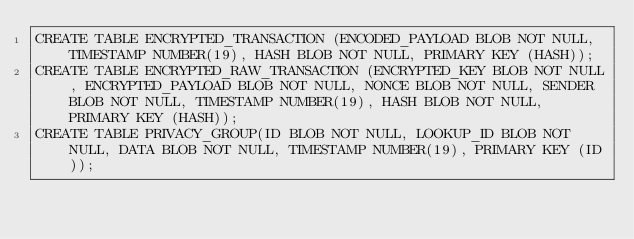<code> <loc_0><loc_0><loc_500><loc_500><_SQL_>CREATE TABLE ENCRYPTED_TRANSACTION (ENCODED_PAYLOAD BLOB NOT NULL, TIMESTAMP NUMBER(19), HASH BLOB NOT NULL, PRIMARY KEY (HASH));
CREATE TABLE ENCRYPTED_RAW_TRANSACTION (ENCRYPTED_KEY BLOB NOT NULL, ENCRYPTED_PAYLOAD BLOB NOT NULL, NONCE BLOB NOT NULL, SENDER BLOB NOT NULL, TIMESTAMP NUMBER(19), HASH BLOB NOT NULL, PRIMARY KEY (HASH));
CREATE TABLE PRIVACY_GROUP(ID BLOB NOT NULL, LOOKUP_ID BLOB NOT NULL, DATA BLOB NOT NULL, TIMESTAMP NUMBER(19), PRIMARY KEY (ID));
</code> 